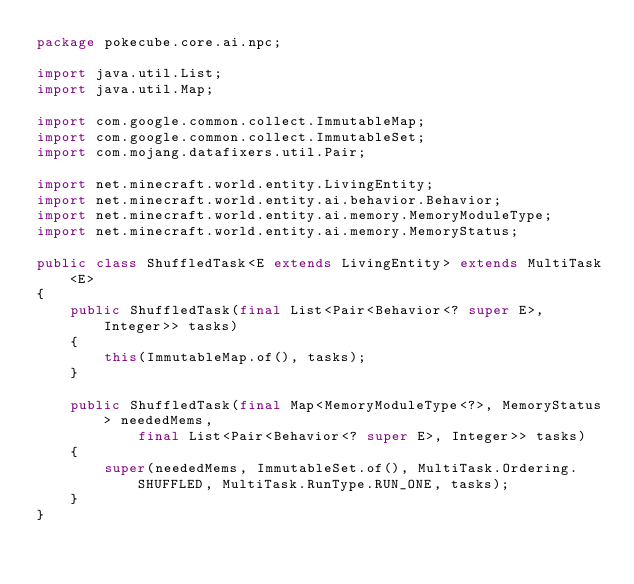Convert code to text. <code><loc_0><loc_0><loc_500><loc_500><_Java_>package pokecube.core.ai.npc;

import java.util.List;
import java.util.Map;

import com.google.common.collect.ImmutableMap;
import com.google.common.collect.ImmutableSet;
import com.mojang.datafixers.util.Pair;

import net.minecraft.world.entity.LivingEntity;
import net.minecraft.world.entity.ai.behavior.Behavior;
import net.minecraft.world.entity.ai.memory.MemoryModuleType;
import net.minecraft.world.entity.ai.memory.MemoryStatus;

public class ShuffledTask<E extends LivingEntity> extends MultiTask<E>
{
    public ShuffledTask(final List<Pair<Behavior<? super E>, Integer>> tasks)
    {
        this(ImmutableMap.of(), tasks);
    }

    public ShuffledTask(final Map<MemoryModuleType<?>, MemoryStatus> neededMems,
            final List<Pair<Behavior<? super E>, Integer>> tasks)
    {
        super(neededMems, ImmutableSet.of(), MultiTask.Ordering.SHUFFLED, MultiTask.RunType.RUN_ONE, tasks);
    }
}
</code> 